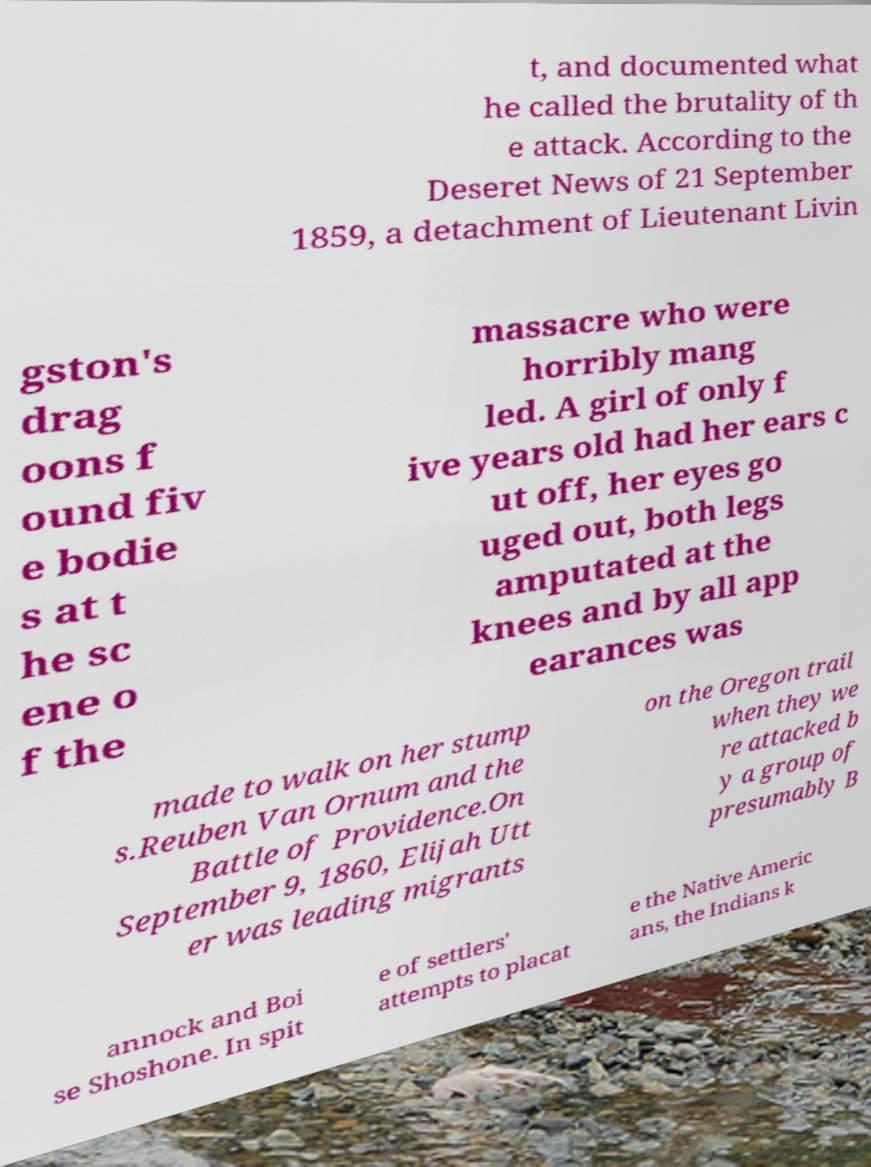Can you accurately transcribe the text from the provided image for me? t, and documented what he called the brutality of th e attack. According to the Deseret News of 21 September 1859, a detachment of Lieutenant Livin gston's drag oons f ound fiv e bodie s at t he sc ene o f the massacre who were horribly mang led. A girl of only f ive years old had her ears c ut off, her eyes go uged out, both legs amputated at the knees and by all app earances was made to walk on her stump s.Reuben Van Ornum and the Battle of Providence.On September 9, 1860, Elijah Utt er was leading migrants on the Oregon trail when they we re attacked b y a group of presumably B annock and Boi se Shoshone. In spit e of settlers' attempts to placat e the Native Americ ans, the Indians k 